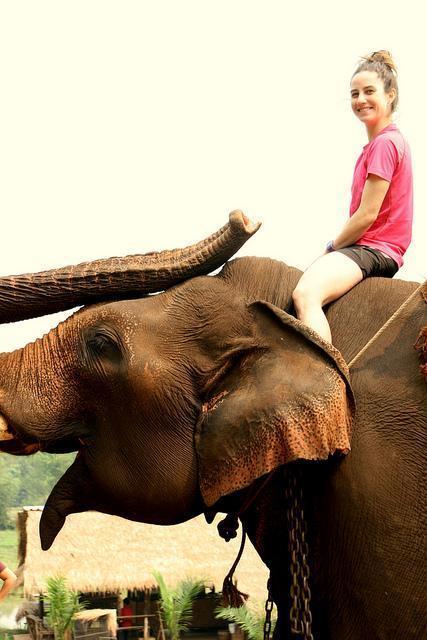How many motorcycles are there in the image?
Give a very brief answer. 0. 